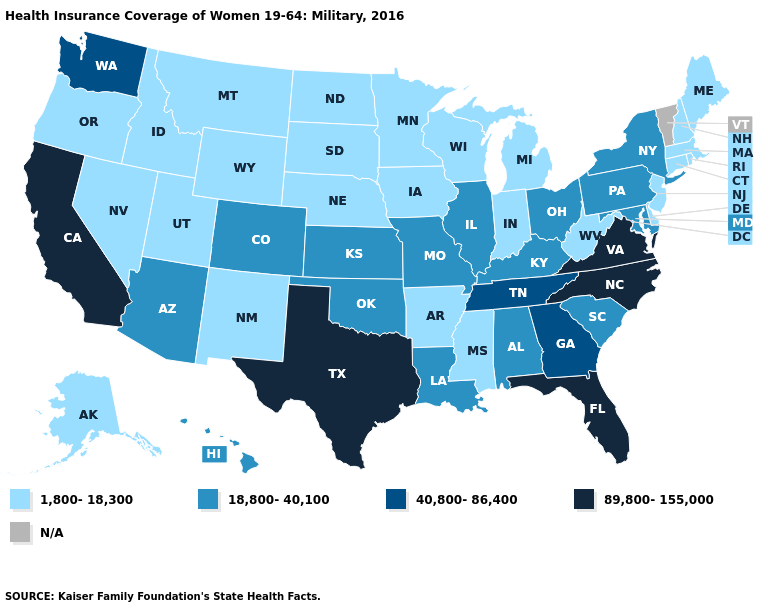What is the lowest value in states that border Oklahoma?
Short answer required. 1,800-18,300. Does Massachusetts have the highest value in the Northeast?
Answer briefly. No. What is the value of Pennsylvania?
Give a very brief answer. 18,800-40,100. What is the value of New Jersey?
Write a very short answer. 1,800-18,300. Which states have the lowest value in the USA?
Short answer required. Alaska, Arkansas, Connecticut, Delaware, Idaho, Indiana, Iowa, Maine, Massachusetts, Michigan, Minnesota, Mississippi, Montana, Nebraska, Nevada, New Hampshire, New Jersey, New Mexico, North Dakota, Oregon, Rhode Island, South Dakota, Utah, West Virginia, Wisconsin, Wyoming. Which states have the lowest value in the South?
Answer briefly. Arkansas, Delaware, Mississippi, West Virginia. Name the states that have a value in the range 89,800-155,000?
Quick response, please. California, Florida, North Carolina, Texas, Virginia. What is the value of California?
Be succinct. 89,800-155,000. What is the value of Wyoming?
Answer briefly. 1,800-18,300. Name the states that have a value in the range 1,800-18,300?
Concise answer only. Alaska, Arkansas, Connecticut, Delaware, Idaho, Indiana, Iowa, Maine, Massachusetts, Michigan, Minnesota, Mississippi, Montana, Nebraska, Nevada, New Hampshire, New Jersey, New Mexico, North Dakota, Oregon, Rhode Island, South Dakota, Utah, West Virginia, Wisconsin, Wyoming. What is the lowest value in the Northeast?
Write a very short answer. 1,800-18,300. What is the value of Indiana?
Short answer required. 1,800-18,300. Name the states that have a value in the range N/A?
Keep it brief. Vermont. What is the lowest value in the USA?
Answer briefly. 1,800-18,300. Which states have the highest value in the USA?
Short answer required. California, Florida, North Carolina, Texas, Virginia. 